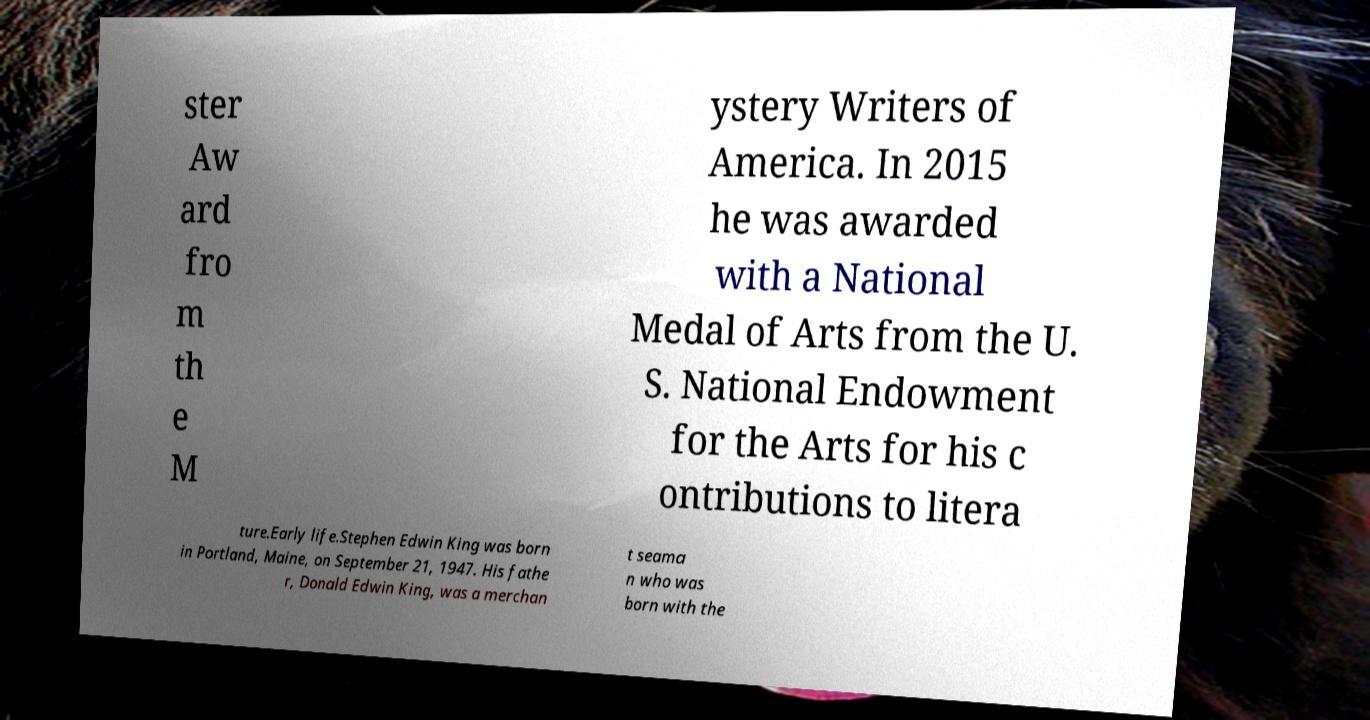There's text embedded in this image that I need extracted. Can you transcribe it verbatim? ster Aw ard fro m th e M ystery Writers of America. In 2015 he was awarded with a National Medal of Arts from the U. S. National Endowment for the Arts for his c ontributions to litera ture.Early life.Stephen Edwin King was born in Portland, Maine, on September 21, 1947. His fathe r, Donald Edwin King, was a merchan t seama n who was born with the 